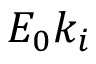Convert formula to latex. <formula><loc_0><loc_0><loc_500><loc_500>E _ { 0 } k _ { i }</formula> 